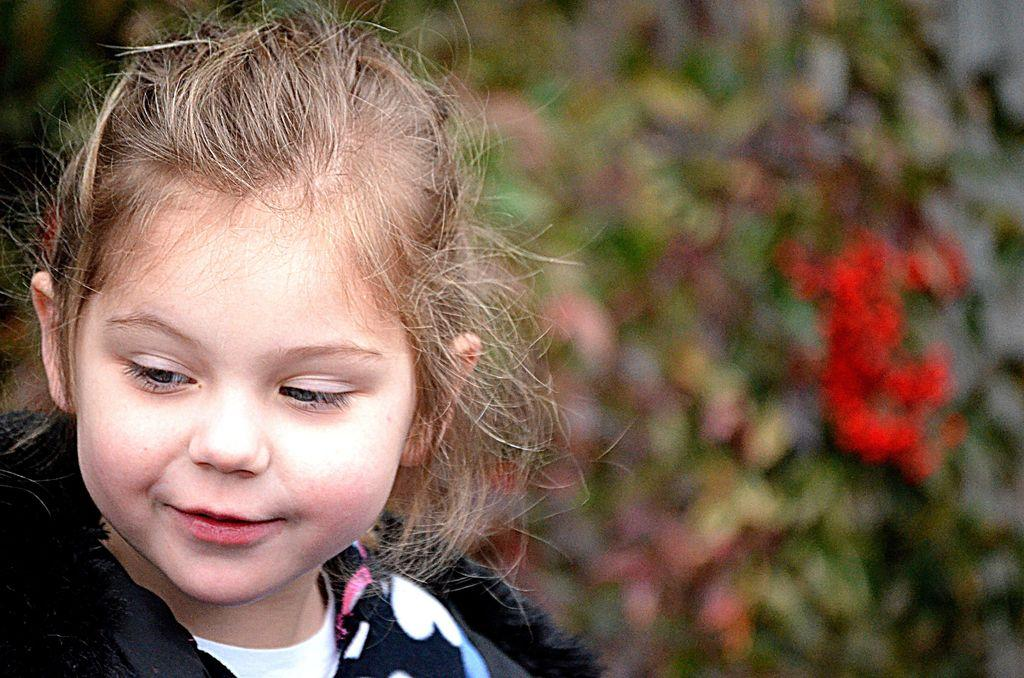Who is the main subject in the foreground of the image? There is a girl in the foreground of the image. What can be seen in the background of the image? There are plants and flowers in the background of the image. What type of ship can be seen sailing in the background of the image? There is no ship present in the image; it only features a girl in the foreground and plants and flowers in the background. 